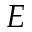<formula> <loc_0><loc_0><loc_500><loc_500>E</formula> 